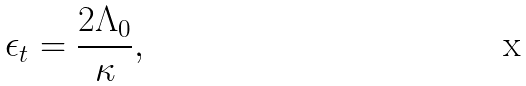<formula> <loc_0><loc_0><loc_500><loc_500>\epsilon _ { t } = \frac { 2 \Lambda _ { 0 } } { \kappa } ,</formula> 